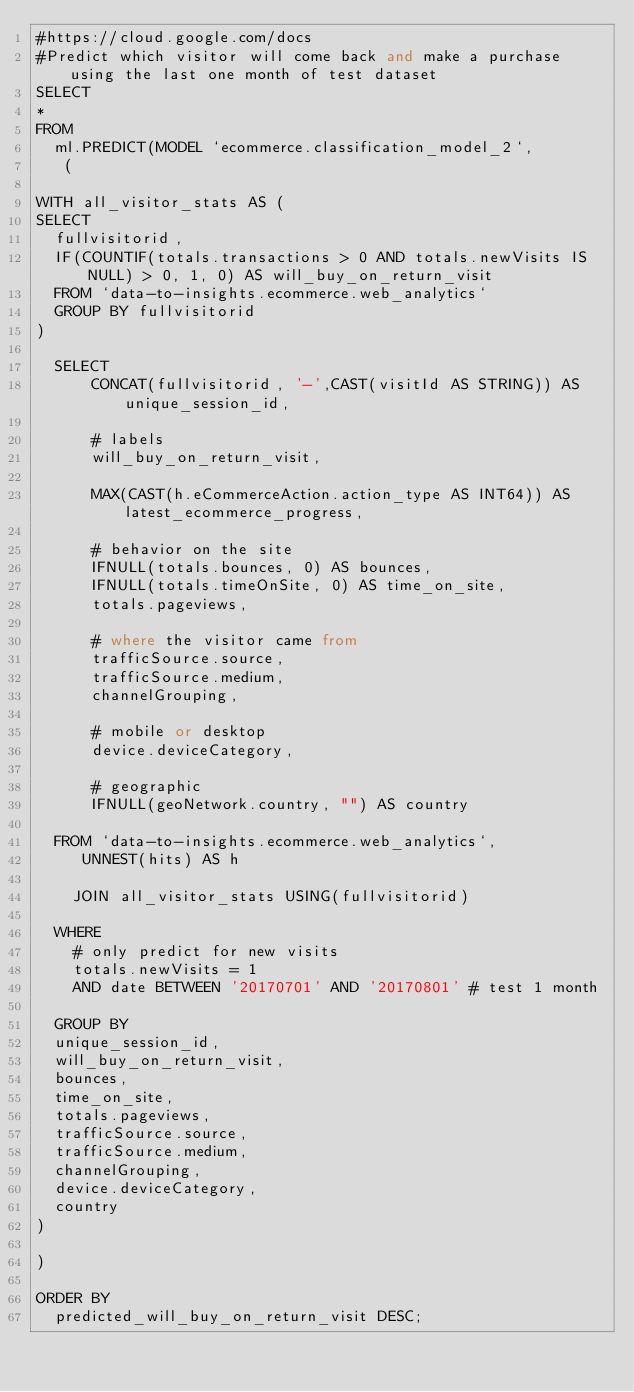Convert code to text. <code><loc_0><loc_0><loc_500><loc_500><_SQL_>#https://cloud.google.com/docs
#Predict which visitor will come back and make a purchase using the last one month of test dataset
SELECT
*
FROM
  ml.PREDICT(MODEL `ecommerce.classification_model_2`,
   (

WITH all_visitor_stats AS (
SELECT
  fullvisitorid,
  IF(COUNTIF(totals.transactions > 0 AND totals.newVisits IS NULL) > 0, 1, 0) AS will_buy_on_return_visit
  FROM `data-to-insights.ecommerce.web_analytics`
  GROUP BY fullvisitorid
)

  SELECT
      CONCAT(fullvisitorid, '-',CAST(visitId AS STRING)) AS unique_session_id,

      # labels
      will_buy_on_return_visit,

      MAX(CAST(h.eCommerceAction.action_type AS INT64)) AS latest_ecommerce_progress,

      # behavior on the site
      IFNULL(totals.bounces, 0) AS bounces,
      IFNULL(totals.timeOnSite, 0) AS time_on_site,
      totals.pageviews,

      # where the visitor came from
      trafficSource.source,
      trafficSource.medium,
      channelGrouping,

      # mobile or desktop
      device.deviceCategory,

      # geographic
      IFNULL(geoNetwork.country, "") AS country

  FROM `data-to-insights.ecommerce.web_analytics`,
     UNNEST(hits) AS h

    JOIN all_visitor_stats USING(fullvisitorid)

  WHERE
    # only predict for new visits
    totals.newVisits = 1
    AND date BETWEEN '20170701' AND '20170801' # test 1 month

  GROUP BY
  unique_session_id,
  will_buy_on_return_visit,
  bounces,
  time_on_site,
  totals.pageviews,
  trafficSource.source,
  trafficSource.medium,
  channelGrouping,
  device.deviceCategory,
  country
)

)

ORDER BY
  predicted_will_buy_on_return_visit DESC;
</code> 